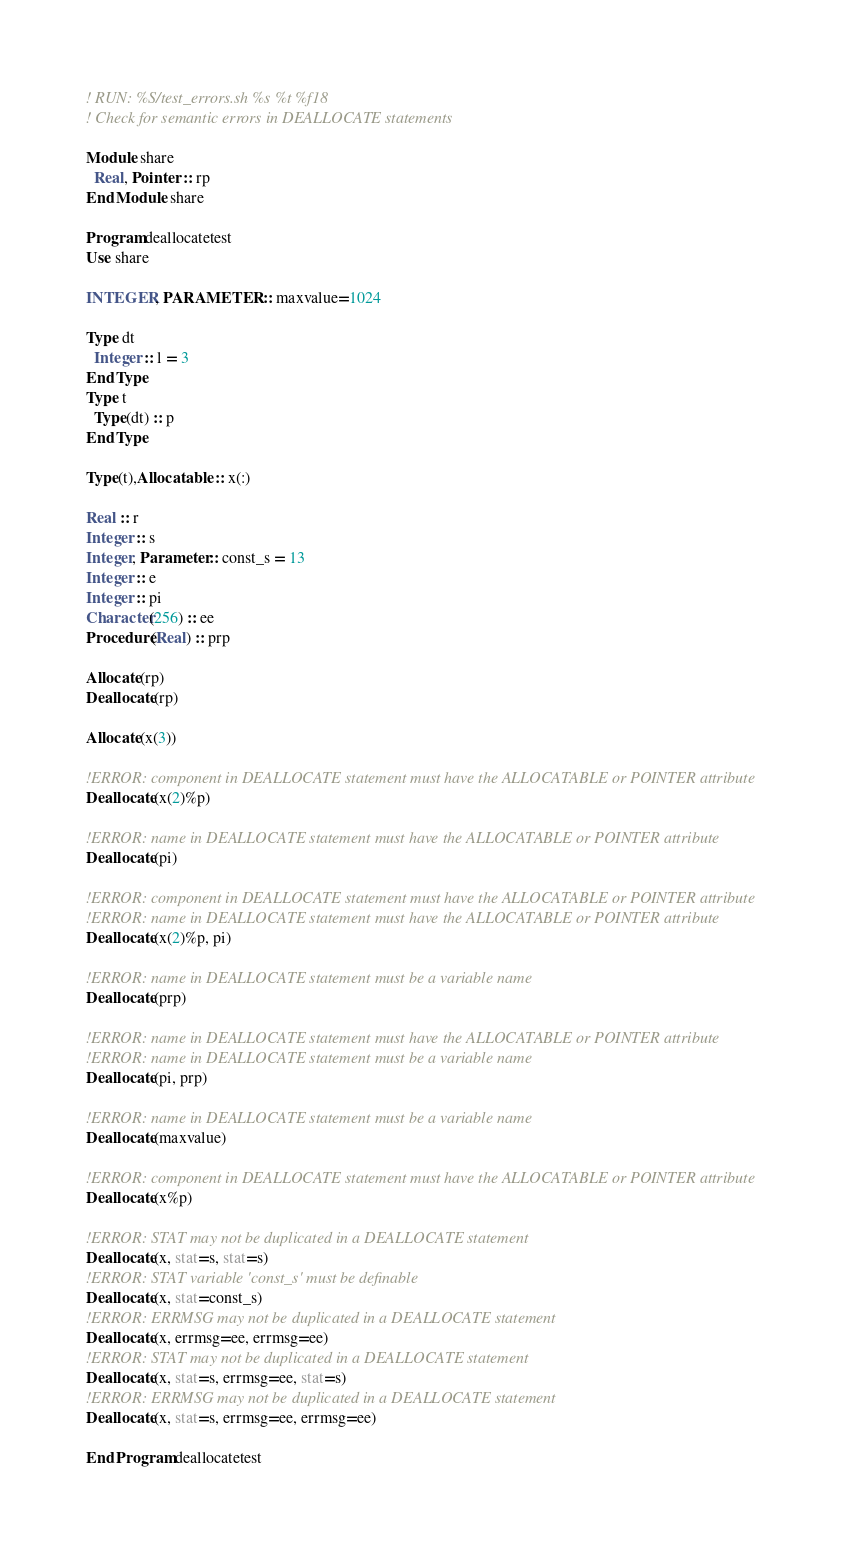Convert code to text. <code><loc_0><loc_0><loc_500><loc_500><_FORTRAN_>! RUN: %S/test_errors.sh %s %t %f18
! Check for semantic errors in DEALLOCATE statements

Module share
  Real, Pointer :: rp
End Module share

Program deallocatetest
Use share

INTEGER, PARAMETER :: maxvalue=1024

Type dt
  Integer :: l = 3
End Type
Type t
  Type(dt) :: p
End Type

Type(t),Allocatable :: x(:)

Real :: r
Integer :: s
Integer, Parameter :: const_s = 13
Integer :: e
Integer :: pi
Character(256) :: ee
Procedure(Real) :: prp

Allocate(rp)
Deallocate(rp)

Allocate(x(3))

!ERROR: component in DEALLOCATE statement must have the ALLOCATABLE or POINTER attribute
Deallocate(x(2)%p)

!ERROR: name in DEALLOCATE statement must have the ALLOCATABLE or POINTER attribute
Deallocate(pi)

!ERROR: component in DEALLOCATE statement must have the ALLOCATABLE or POINTER attribute
!ERROR: name in DEALLOCATE statement must have the ALLOCATABLE or POINTER attribute
Deallocate(x(2)%p, pi)

!ERROR: name in DEALLOCATE statement must be a variable name
Deallocate(prp)

!ERROR: name in DEALLOCATE statement must have the ALLOCATABLE or POINTER attribute
!ERROR: name in DEALLOCATE statement must be a variable name
Deallocate(pi, prp)

!ERROR: name in DEALLOCATE statement must be a variable name
Deallocate(maxvalue)

!ERROR: component in DEALLOCATE statement must have the ALLOCATABLE or POINTER attribute
Deallocate(x%p)

!ERROR: STAT may not be duplicated in a DEALLOCATE statement
Deallocate(x, stat=s, stat=s)
!ERROR: STAT variable 'const_s' must be definable
Deallocate(x, stat=const_s)
!ERROR: ERRMSG may not be duplicated in a DEALLOCATE statement
Deallocate(x, errmsg=ee, errmsg=ee)
!ERROR: STAT may not be duplicated in a DEALLOCATE statement
Deallocate(x, stat=s, errmsg=ee, stat=s)
!ERROR: ERRMSG may not be duplicated in a DEALLOCATE statement
Deallocate(x, stat=s, errmsg=ee, errmsg=ee)

End Program deallocatetest
</code> 